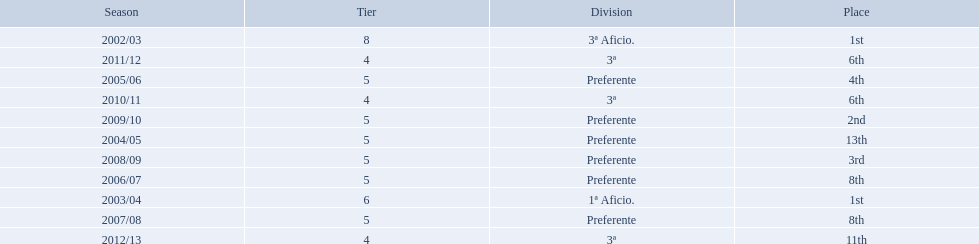Which seasons were played in tier four? 2010/11, 2011/12, 2012/13. Of these seasons, which resulted in 6th place? 2010/11, 2011/12. Which of the remaining happened last? 2011/12. 